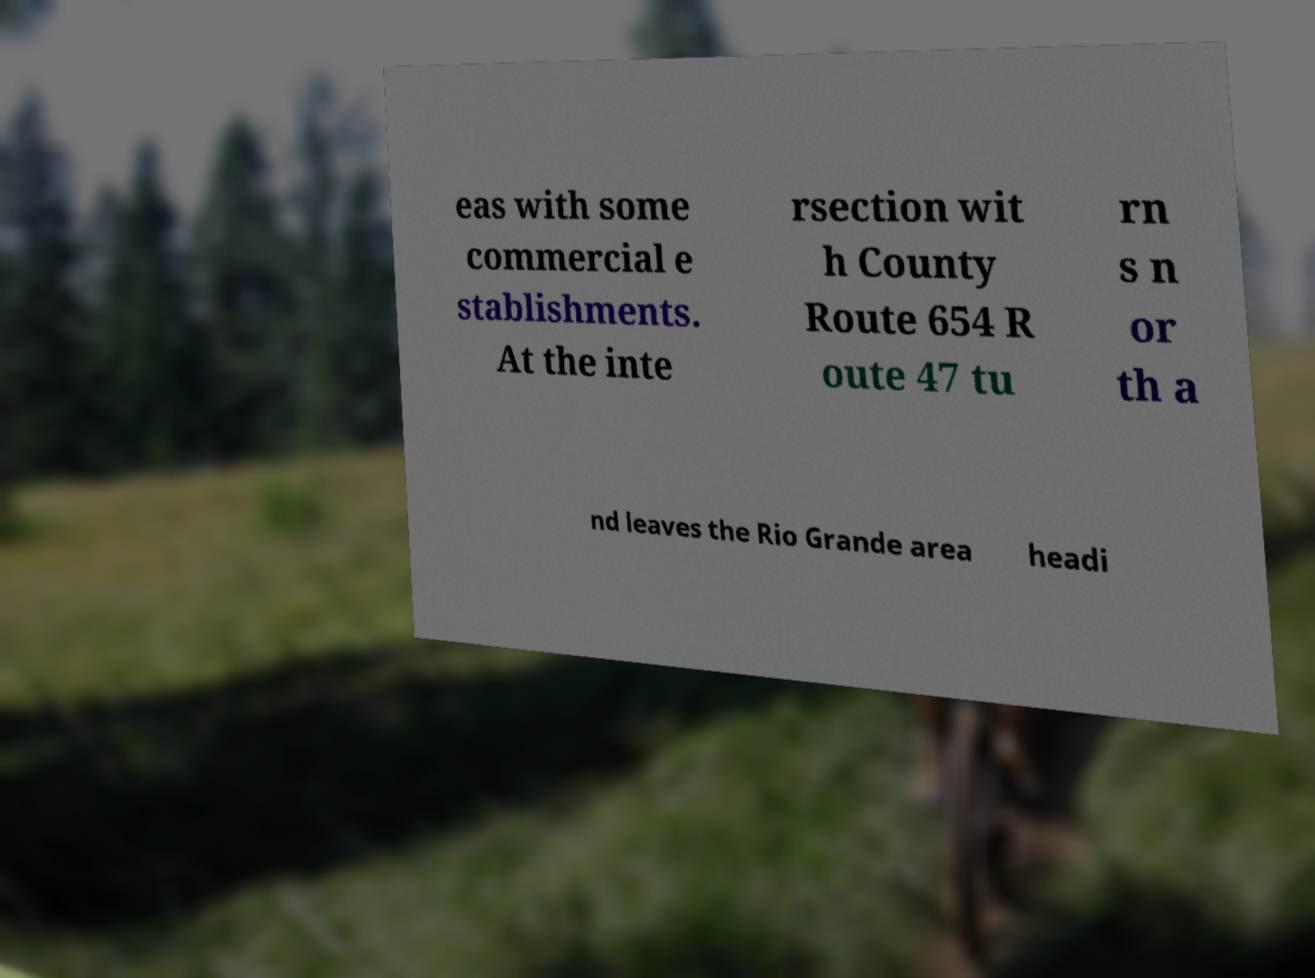Can you accurately transcribe the text from the provided image for me? eas with some commercial e stablishments. At the inte rsection wit h County Route 654 R oute 47 tu rn s n or th a nd leaves the Rio Grande area headi 